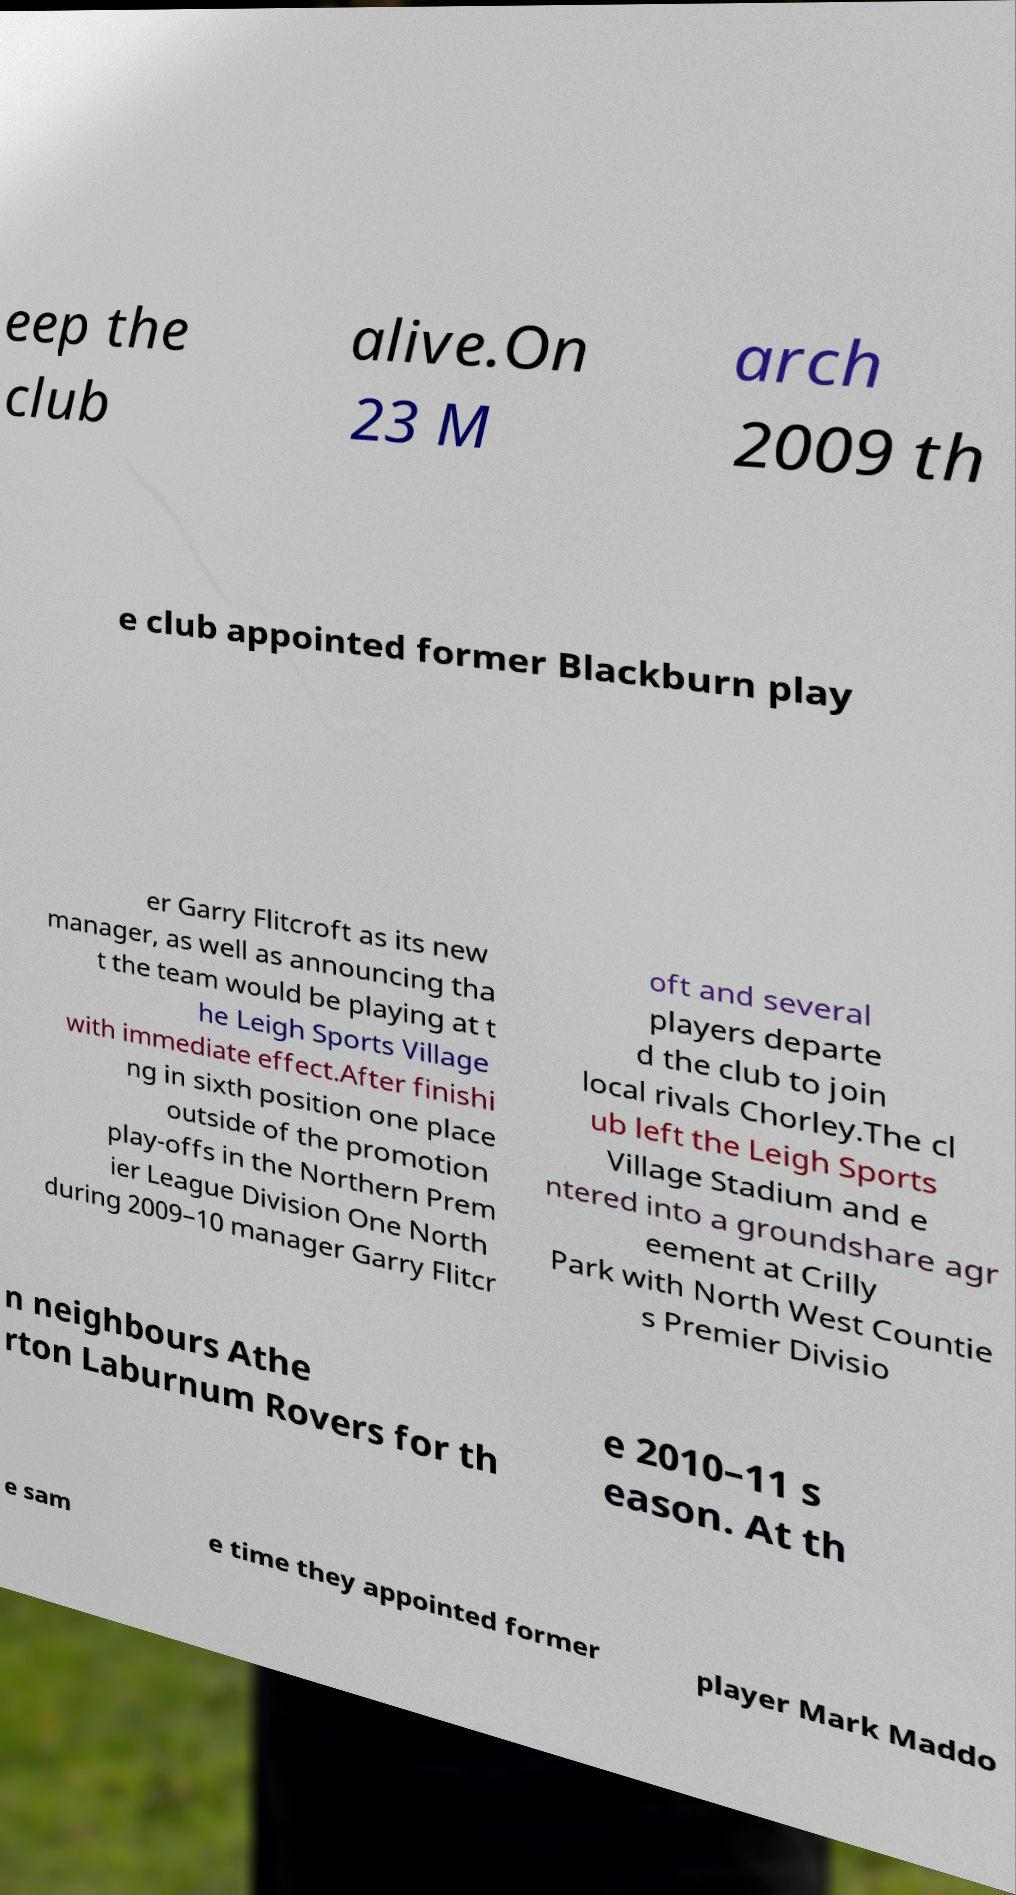Could you extract and type out the text from this image? eep the club alive.On 23 M arch 2009 th e club appointed former Blackburn play er Garry Flitcroft as its new manager, as well as announcing tha t the team would be playing at t he Leigh Sports Village with immediate effect.After finishi ng in sixth position one place outside of the promotion play-offs in the Northern Prem ier League Division One North during 2009–10 manager Garry Flitcr oft and several players departe d the club to join local rivals Chorley.The cl ub left the Leigh Sports Village Stadium and e ntered into a groundshare agr eement at Crilly Park with North West Countie s Premier Divisio n neighbours Athe rton Laburnum Rovers for th e 2010–11 s eason. At th e sam e time they appointed former player Mark Maddo 